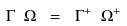Convert formula to latex. <formula><loc_0><loc_0><loc_500><loc_500>\Gamma \ \Omega \ = \ \Gamma ^ { + } \ \Omega ^ { + }</formula> 